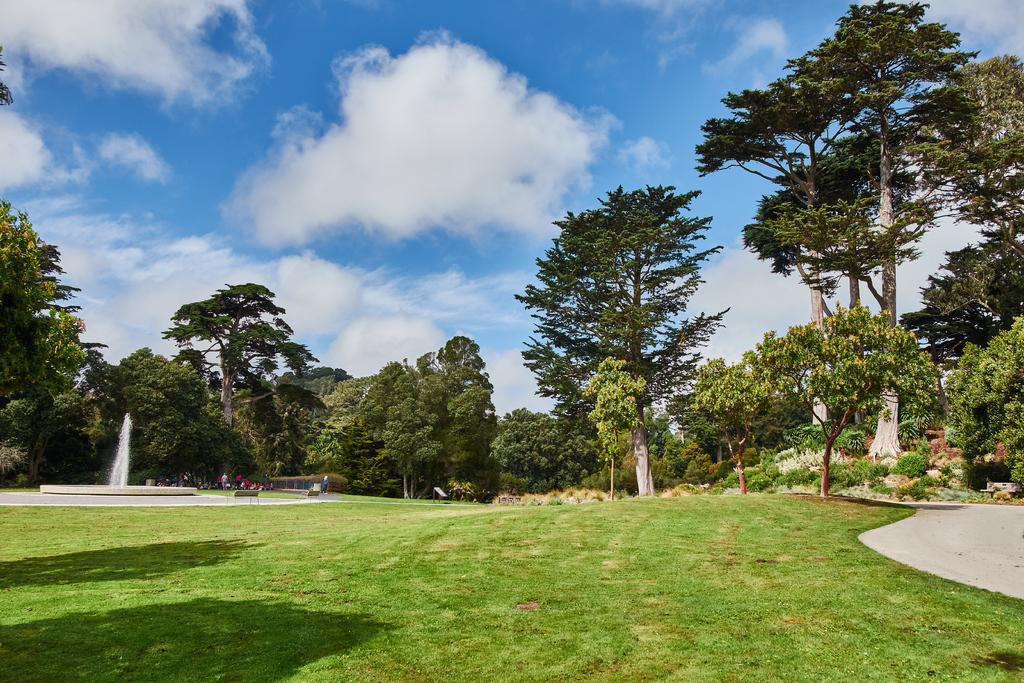What type of vegetation is present in the image? There are trees in the image. What can be seen on the left side of the image? There is a fountain on the left side of the image. What is located on the right side of the image? There is a walkway on the right side of the image. What is visible in the background of the image? The sky is visible in the background of the image. What type of ground surface is at the bottom of the image? There is grass at the bottom of the image. What verse is being recited by the daughter in the image? There is no daughter or verse present in the image. What type of motion is being depicted in the image? The image does not depict any motion; it is a still scene. 